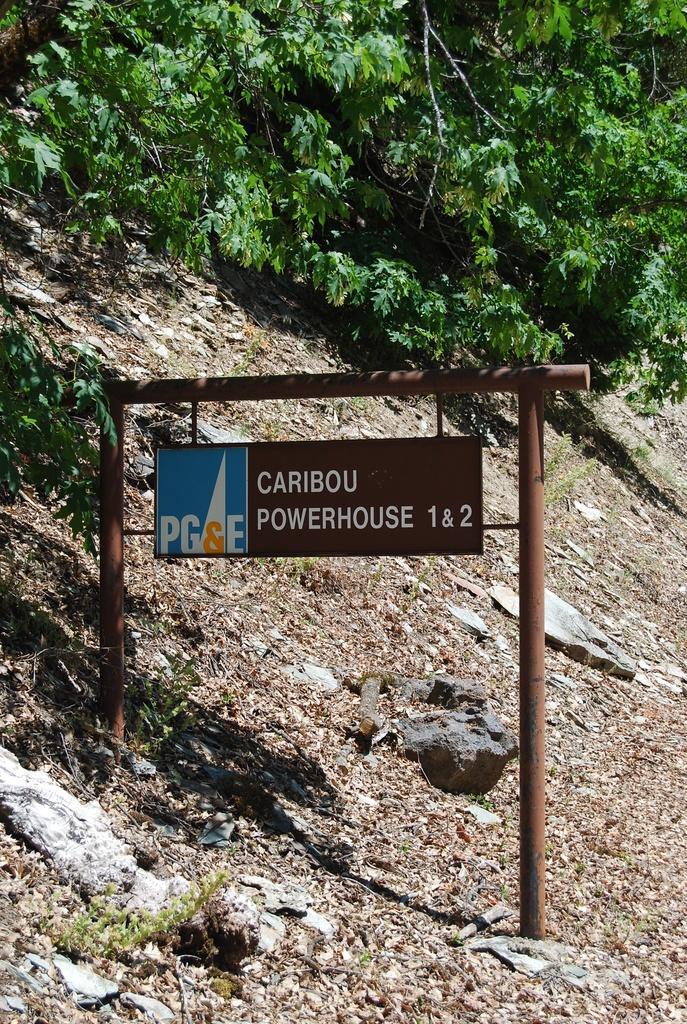In one or two sentences, can you explain what this image depicts? As we can see in the image there are trees and a sign board over here. 